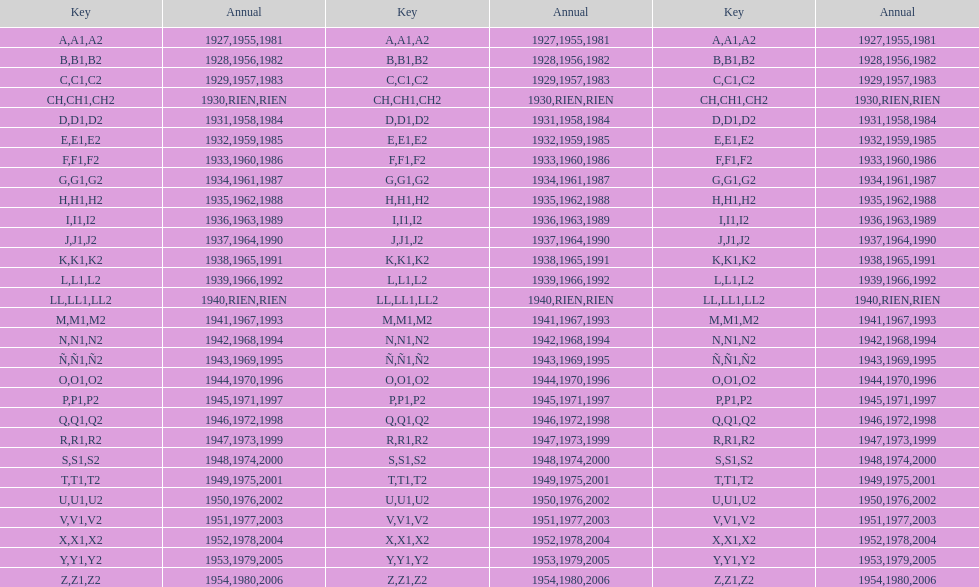Parse the table in full. {'header': ['Key', 'Annual', 'Key', 'Annual', 'Key', 'Annual'], 'rows': [['A', '1927', 'A1', '1955', 'A2', '1981'], ['B', '1928', 'B1', '1956', 'B2', '1982'], ['C', '1929', 'C1', '1957', 'C2', '1983'], ['CH', '1930', 'CH1', 'RIEN', 'CH2', 'RIEN'], ['D', '1931', 'D1', '1958', 'D2', '1984'], ['E', '1932', 'E1', '1959', 'E2', '1985'], ['F', '1933', 'F1', '1960', 'F2', '1986'], ['G', '1934', 'G1', '1961', 'G2', '1987'], ['H', '1935', 'H1', '1962', 'H2', '1988'], ['I', '1936', 'I1', '1963', 'I2', '1989'], ['J', '1937', 'J1', '1964', 'J2', '1990'], ['K', '1938', 'K1', '1965', 'K2', '1991'], ['L', '1939', 'L1', '1966', 'L2', '1992'], ['LL', '1940', 'LL1', 'RIEN', 'LL2', 'RIEN'], ['M', '1941', 'M1', '1967', 'M2', '1993'], ['N', '1942', 'N1', '1968', 'N2', '1994'], ['Ñ', '1943', 'Ñ1', '1969', 'Ñ2', '1995'], ['O', '1944', 'O1', '1970', 'O2', '1996'], ['P', '1945', 'P1', '1971', 'P2', '1997'], ['Q', '1946', 'Q1', '1972', 'Q2', '1998'], ['R', '1947', 'R1', '1973', 'R2', '1999'], ['S', '1948', 'S1', '1974', 'S2', '2000'], ['T', '1949', 'T1', '1975', 'T2', '2001'], ['U', '1950', 'U1', '1976', 'U2', '2002'], ['V', '1951', 'V1', '1977', 'V2', '2003'], ['X', '1952', 'X1', '1978', 'X2', '2004'], ['Y', '1953', 'Y1', '1979', 'Y2', '2005'], ['Z', '1954', 'Z1', '1980', 'Z2', '2006']]} How many different codes were used from 1953 to 1958? 6. 